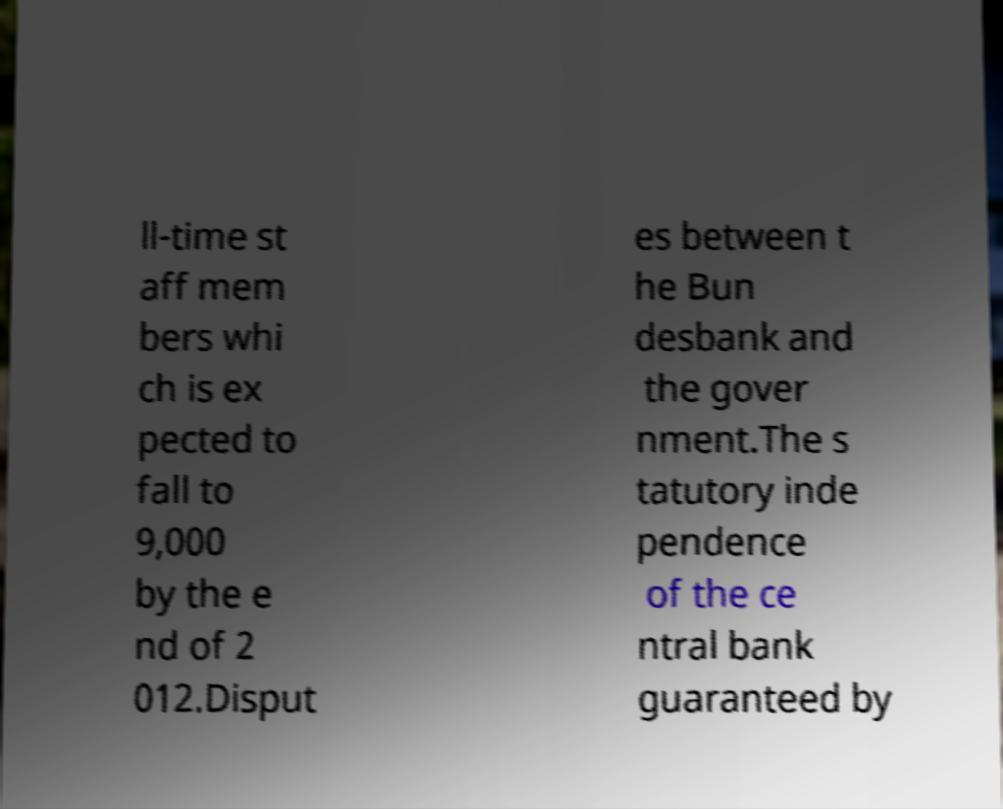What messages or text are displayed in this image? I need them in a readable, typed format. ll-time st aff mem bers whi ch is ex pected to fall to 9,000 by the e nd of 2 012.Disput es between t he Bun desbank and the gover nment.The s tatutory inde pendence of the ce ntral bank guaranteed by 